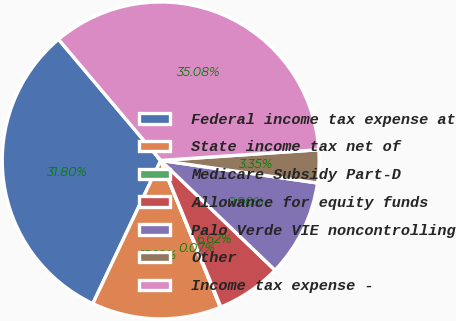<chart> <loc_0><loc_0><loc_500><loc_500><pie_chart><fcel>Federal income tax expense at<fcel>State income tax net of<fcel>Medicare Subsidy Part-D<fcel>Allowance for equity funds<fcel>Palo Verde VIE noncontrolling<fcel>Other<fcel>Income tax expense -<nl><fcel>31.8%<fcel>13.18%<fcel>0.07%<fcel>6.62%<fcel>9.9%<fcel>3.35%<fcel>35.08%<nl></chart> 